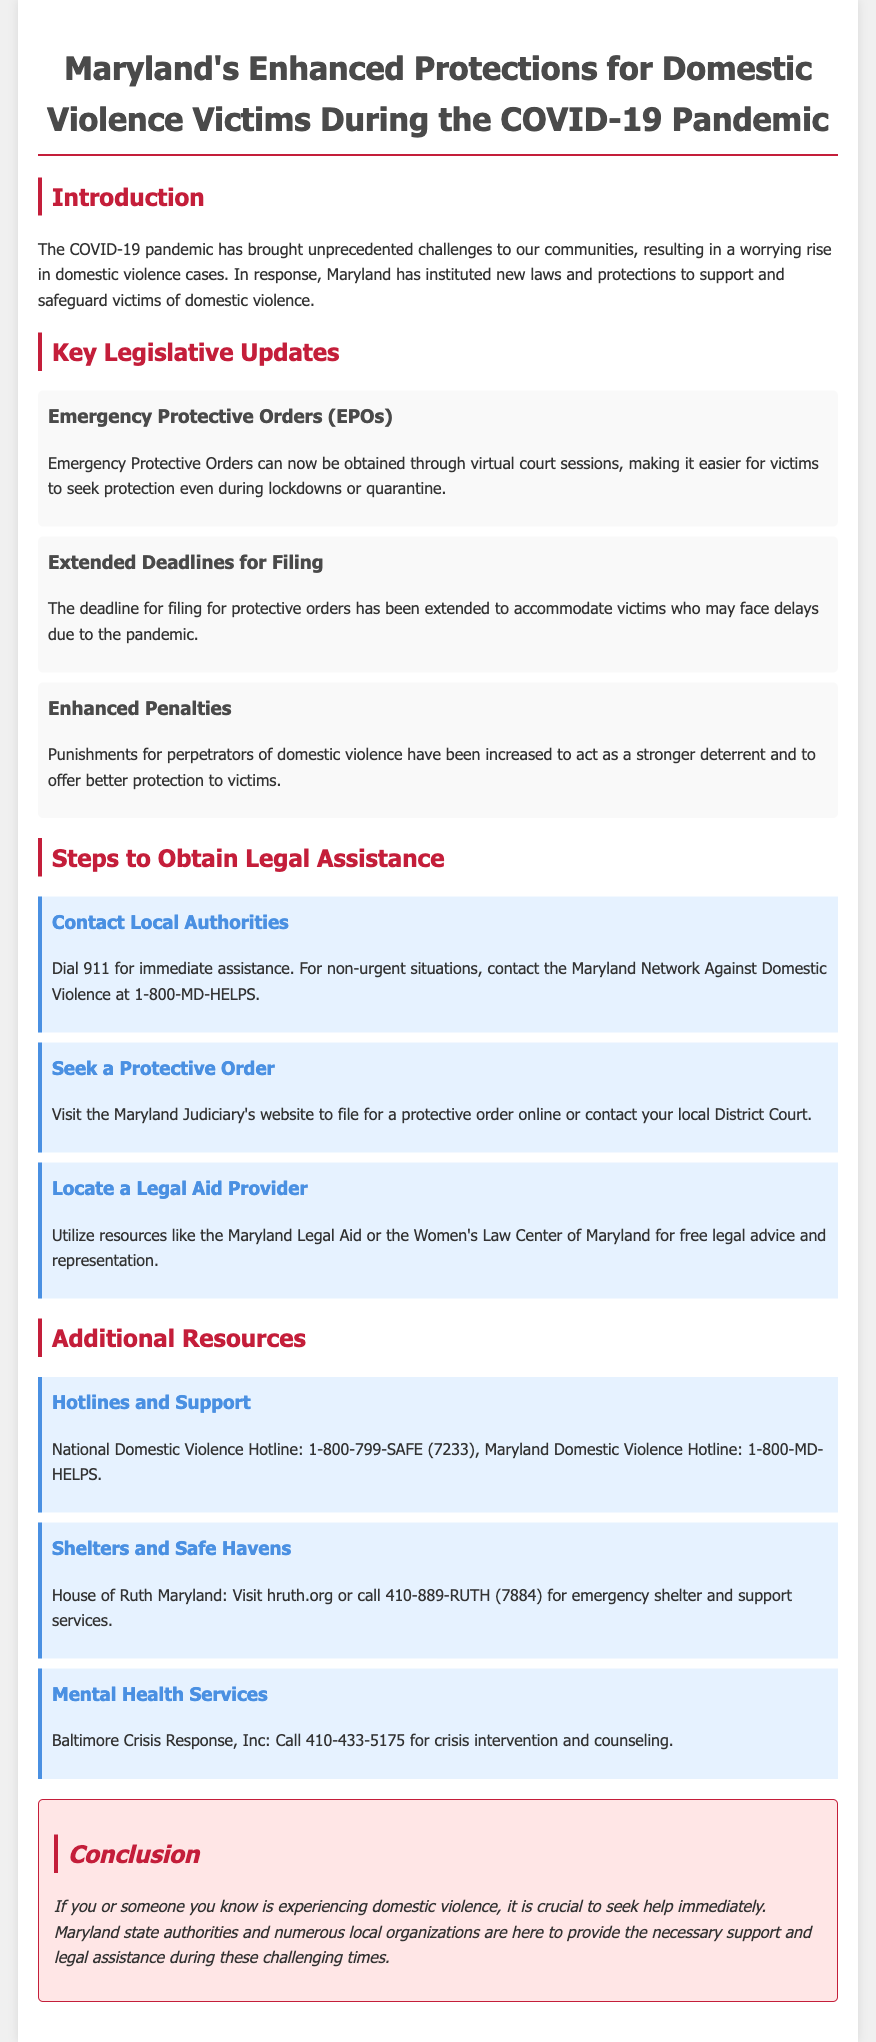What is the title of the document? The title is mentioned at the top of the document as "Maryland's Enhanced Protections for Domestic Violence Victims During the COVID-19 Pandemic."
Answer: Maryland's Enhanced Protections for Domestic Violence Victims During the COVID-19 Pandemic What is the contact number for the Maryland Network Against Domestic Violence? The contact number for the Maryland Network Against Domestic Violence is specified in the document for non-urgent situations.
Answer: 1-800-MD-HELPS What type of orders can now be obtained through virtual court sessions? The specific type of orders that can be obtained through virtual court sessions is highlighted in the section about Emergency Protective Orders.
Answer: Emergency Protective Orders (EPOs) What increased punitive measure has been implemented for domestic violence perpetrators? The document mentions the enhancement in the severity of consequences for perpetrators as a key legislative update.
Answer: Enhanced Penalties What is the purpose of the new laws mentioned in the brochure? The document states the purpose of the new laws is to offer support and safeguard to victims amidst rising domestic violence cases.
Answer: Support and safeguard victims What is one resource listed for mental health services? The document provides information about a specific organization that offers mental health support, including its contact number.
Answer: Baltimore Crisis Response, Inc How has the deadline for filing protective orders changed? The document indicates that the deadline for filing protective orders has been modified due to the pandemic.
Answer: Extended What is a required action for immediate assistance in a domestic violence situation? The document emphasizes the importance of contacting authorities in emergency situations.
Answer: Dial 911 Where can someone check for filing a protective order online? The document advises to visit a specific website for filing protective orders online.
Answer: Maryland Judiciary's website 